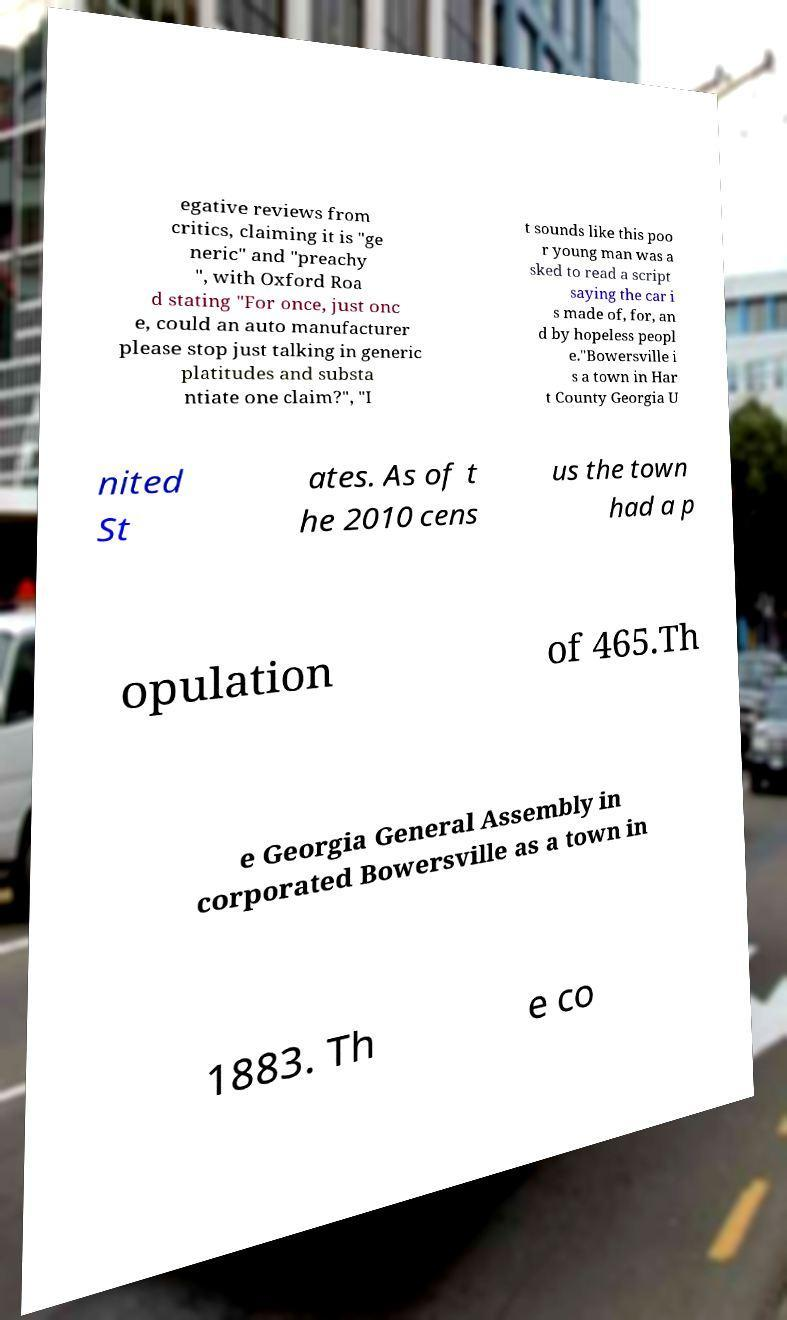Can you read and provide the text displayed in the image?This photo seems to have some interesting text. Can you extract and type it out for me? egative reviews from critics, claiming it is "ge neric" and "preachy ", with Oxford Roa d stating "For once, just onc e, could an auto manufacturer please stop just talking in generic platitudes and substa ntiate one claim?", "I t sounds like this poo r young man was a sked to read a script saying the car i s made of, for, an d by hopeless peopl e."Bowersville i s a town in Har t County Georgia U nited St ates. As of t he 2010 cens us the town had a p opulation of 465.Th e Georgia General Assembly in corporated Bowersville as a town in 1883. Th e co 